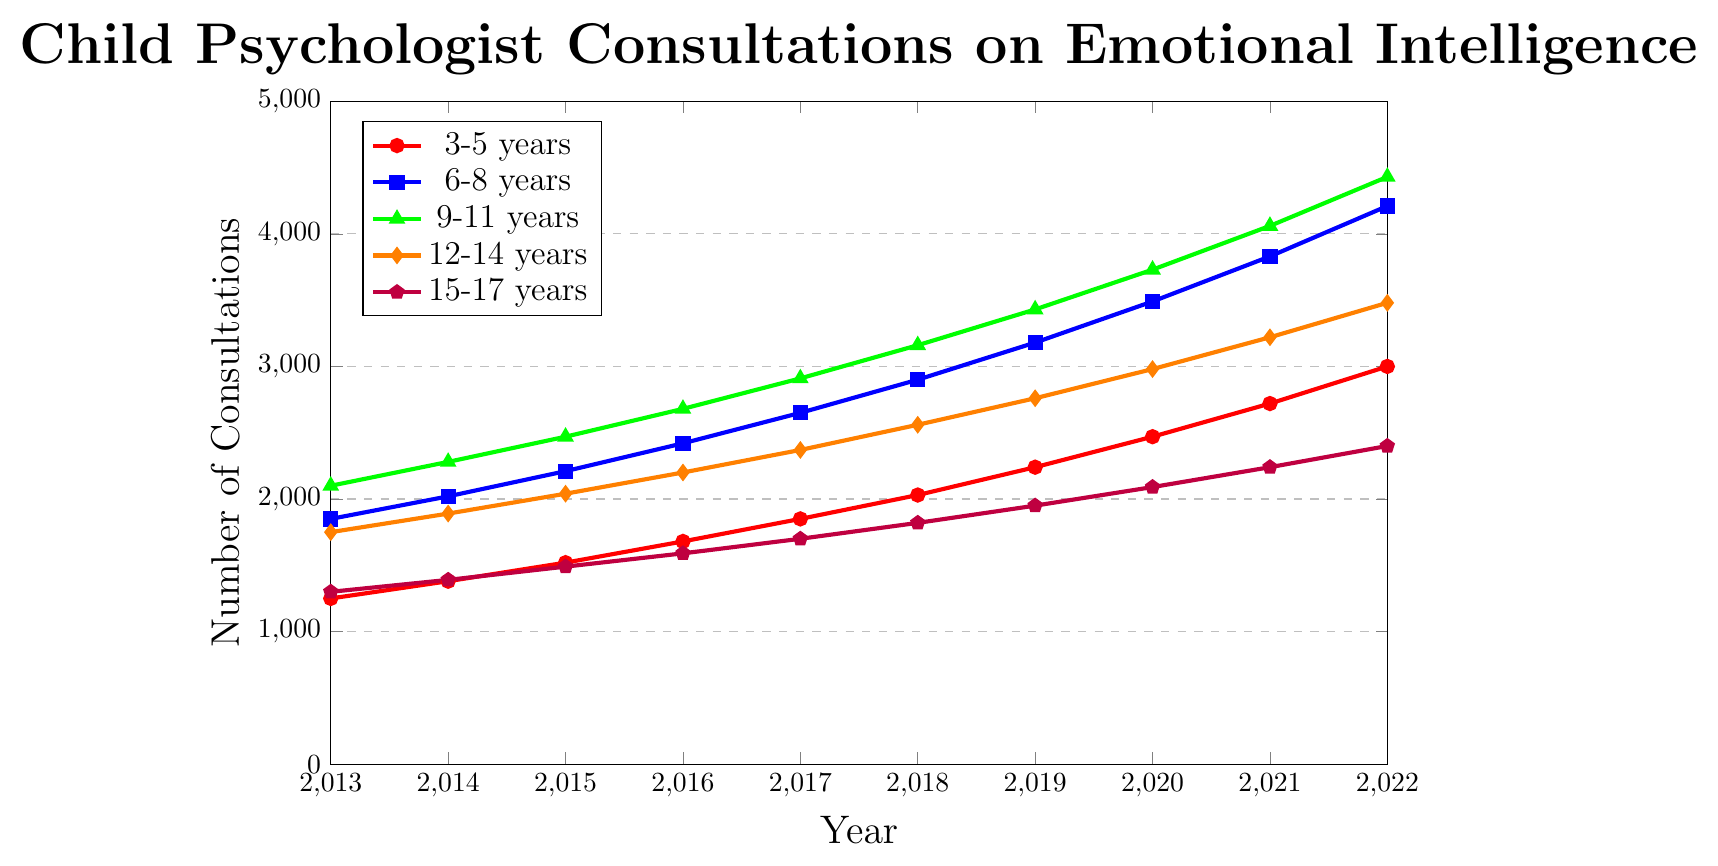What age group had the highest number of consultations each year? Let's examine each year's data points and compare: 9-11 years consistently had the highest values across all years in comparison to other age groups.
Answer: 9-11 years What is the total number of consultations for the 6-8 years age group from 2013 to 2022? The number of consultations for each year is given, so let's sum them up: 1850 + 2020 + 2210 + 2420 + 2650 + 2900 + 3180 + 3490 + 3830 + 4210 = 28760.
Answer: 28760 Did the number of consultations increase more from 2013 to 2022 for the 3-5 years age group or the 15-17 years age group? Compute the difference for each group: For 3-5 years, (3000 - 1250) = 1750, and for 15-17 years, (2400 - 1300) = 1100. The increase in consultations for the 3-5 years age group was higher.
Answer: 3-5 years Which age group has the steepest increase in consultations from 2019 to 2020? Calculate the change in consultations from 2019 to 2020 for each group and compare: For 3-5 years, (2470 - 2240) = 230; 6-8 years, (3490 - 3180) = 310; 9-11 years, (3730 - 3430) = 300; 12-14 years, (2980 - 2760) = 220; 15-17 years, (2090 - 1950) = 140. The 6-8 years group has the steepest increase.
Answer: 6-8 years How many more consultations did the 9-11 years group have in 2022 compared to the 12-14 years group? Subtract the number of consultations for 12-14 years from 9-11 years in 2022: (4430 - 3480) = 950.
Answer: 950 What was the average number of consultations for the 12-14 years group over the entire period? Sum the number of consultations for 12-14 years group and then divide by the number of years: (1750 + 1890 + 2040 + 2200 + 2370 + 2560 + 2760 + 2980 + 3220 + 3480) / 10 = 2525.
Answer: 2525 Which age group had the slowest increase rate from 2013 to 2022? Compute the increase for each group and compare: 3-5 years (3000 - 1250) = 1750; 6-8 years (4210 - 1850) = 2360; 9-11 years (4430 - 2100) = 2330; 12-14 years (3480 - 1750) = 1730; 15-17 years (2400 - 1300) = 1100. The 15-17 years group had the slowest increase.
Answer: 15-17 years In which year did the 3-5 years age group see the largest single-year increase in consultations? Compare the year-to-year differences for the 3-5 years group: 2013-2014 (1380 - 1250) = 130; 2014-2015 (1520 - 1380) = 140; 2015-2016 (1680 - 1520) = 160; 2016-2017 (1850 - 1680) = 170; 2017-2018 (2030 - 1850) = 180; 2018-2019 (2240 - 2030) = 210; 2019-2020 (2470 - 2240) = 230; 2020-2021 (2720 - 2470) = 250; 2021-2022 (3000 - 2720) = 280. The largest increase occurred in 2021-2022.
Answer: 2021-2022 